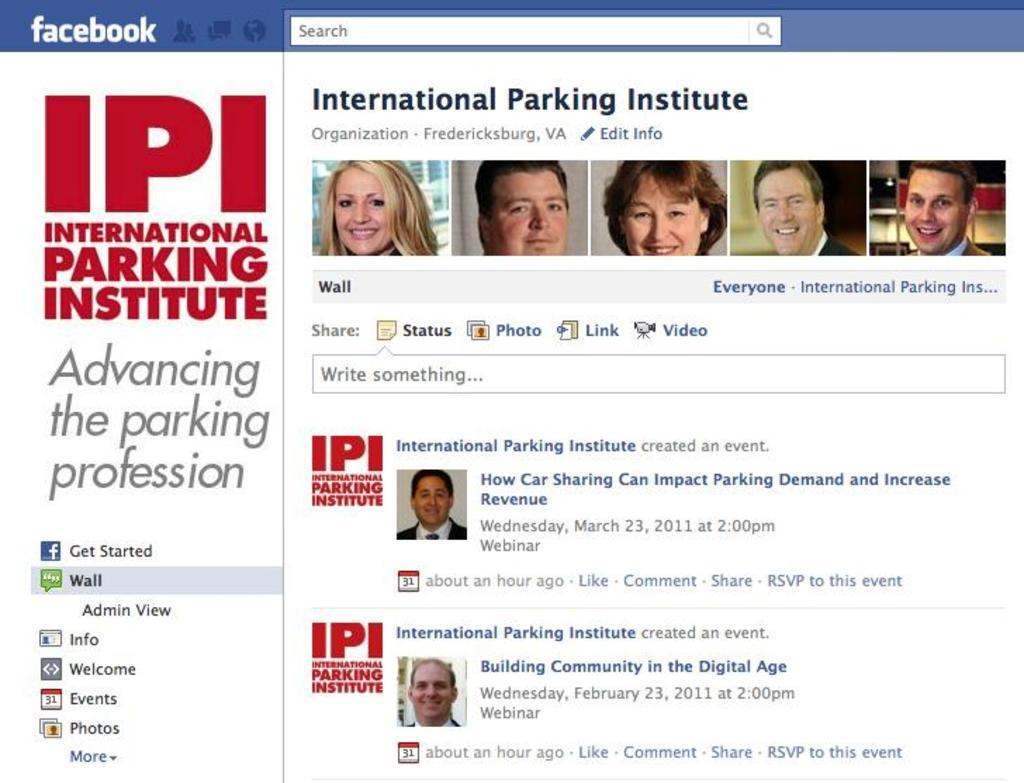What type of page is shown in the image? The image is a screenshot of a Facebook page. What can be seen at the top of the page? There are six photographs of men and women at the top of the page. What is located on the left side of the page? There are quotes and matter on the left side of the page. How many clocks are visible in the image? There are no clocks visible in the image. Are there any kittens playing with a mask in the image? There are no kittens or masks present in the image. 